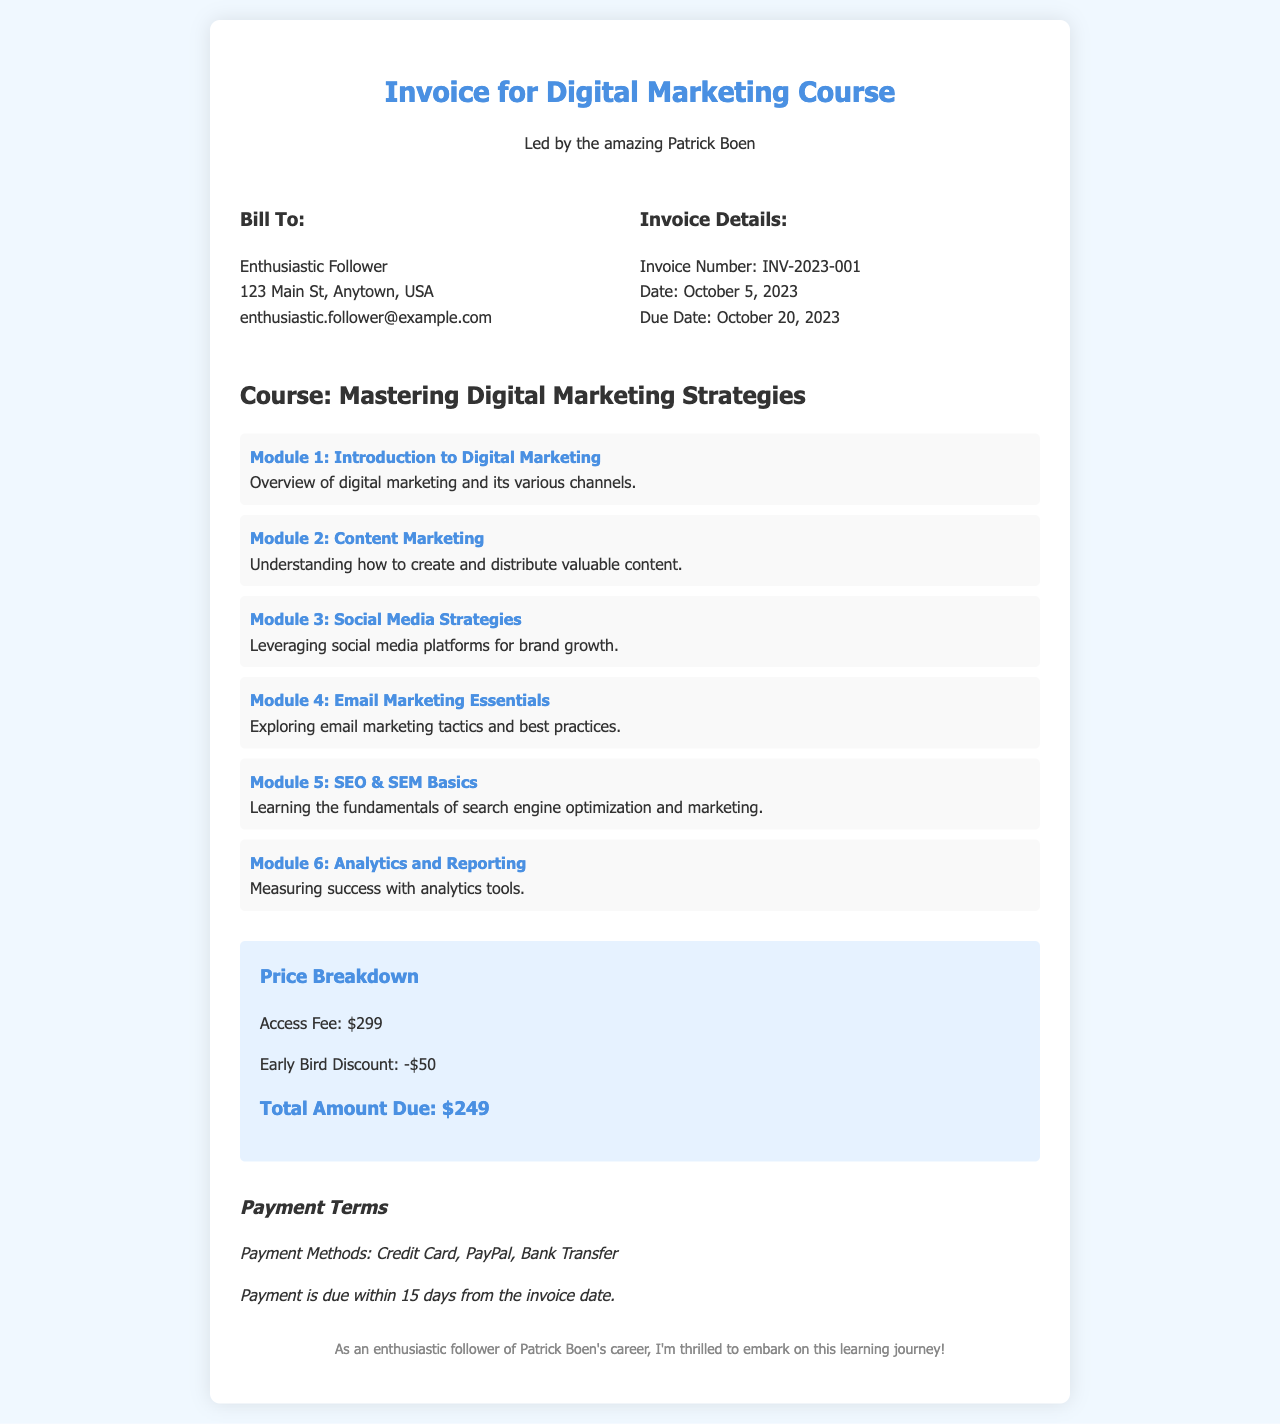What is the invoice number? The invoice number is stated clearly in the invoice details as a unique identifier for the transaction.
Answer: INV-2023-001 What is the course title? The title of the course is prominently displayed and signifies what the invoice is for.
Answer: Mastering Digital Marketing Strategies What is the early bird discount amount? The amount of the early bird discount is indicated in the price breakdown section of the invoice.
Answer: -$50 When is the payment due? The due date for the payment is clearly mentioned in the invoice details, which helps the buyer understand when the payment should be made.
Answer: October 20, 2023 How many modules are included in the course? The number of modules is indicated through a list provided in the course description section.
Answer: 6 What are the payment methods accepted? Accepted payment methods are listed, providing options for how the payment can be made.
Answer: Credit Card, PayPal, Bank Transfer What is the total amount due? The total amount due is specified at the end of the price breakdown section, summarizing the final cost after discounts.
Answer: $249 What is the course instructor's name? The name of the course instructor is mentioned prominently at the beginning of the invoice, indicating the person leading the course.
Answer: Patrick Boen What content does Module 3 cover? The content covered in Module 3 is stated in a brief description following the module title, giving insight into what learners can expect.
Answer: Leveraging social media platforms for brand growth 